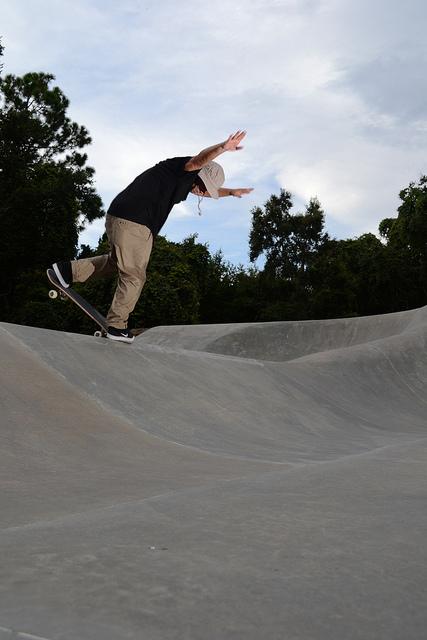Are both of the boys arms above his head?
Keep it brief. Yes. What's the man doing?
Write a very short answer. Skateboarding. Which leg is in the air?
Answer briefly. Left. Is it clear outside?
Write a very short answer. No. Is it cold?
Give a very brief answer. No. 